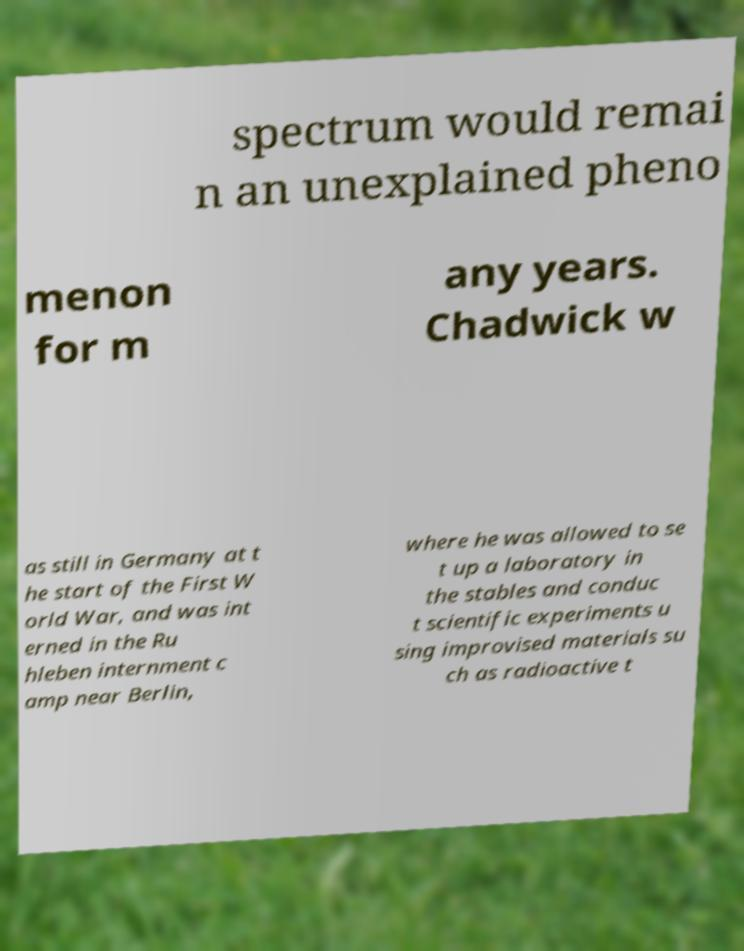What messages or text are displayed in this image? I need them in a readable, typed format. spectrum would remai n an unexplained pheno menon for m any years. Chadwick w as still in Germany at t he start of the First W orld War, and was int erned in the Ru hleben internment c amp near Berlin, where he was allowed to se t up a laboratory in the stables and conduc t scientific experiments u sing improvised materials su ch as radioactive t 